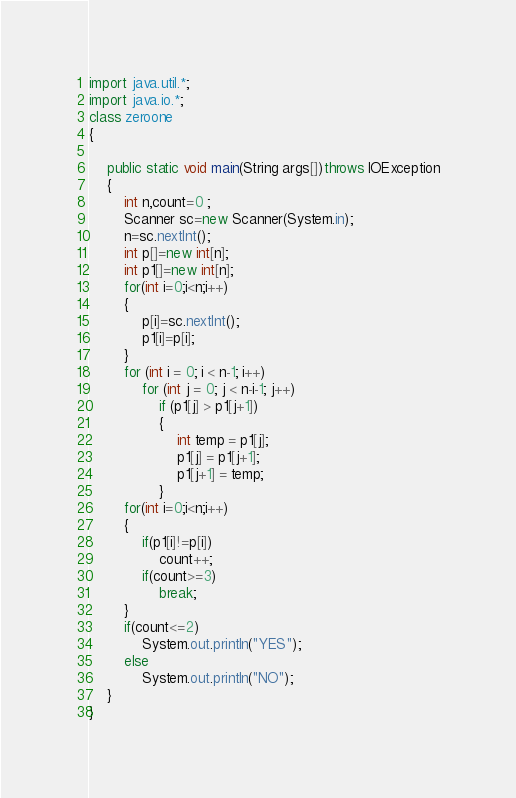Convert code to text. <code><loc_0><loc_0><loc_500><loc_500><_Java_>import java.util.*;
import java.io.*;
class zeroone
{

	public static void main(String args[])throws IOException
	{
		int n,count=0 ;
		Scanner sc=new Scanner(System.in);
		n=sc.nextInt();
		int p[]=new int[n];
		int p1[]=new int[n];
      	for(int i=0;i<n;i++)
      	{
      		p[i]=sc.nextInt();
      		p1[i]=p[i];
      	}
      	for (int i = 0; i < n-1; i++) 
            for (int j = 0; j < n-i-1; j++) 
                if (p1[j] > p1[j+1]) 
                { 
                    int temp = p1[j]; 
                    p1[j] = p1[j+1]; 
                    p1[j+1] = temp; 
                } 
		for(int i=0;i<n;i++)
		{
			if(p1[i]!=p[i])
				count++;
			if(count>=3)
				break;
		}
		if(count<=2)
			System.out.println("YES");
		else
			System.out.println("NO");
	}
}</code> 